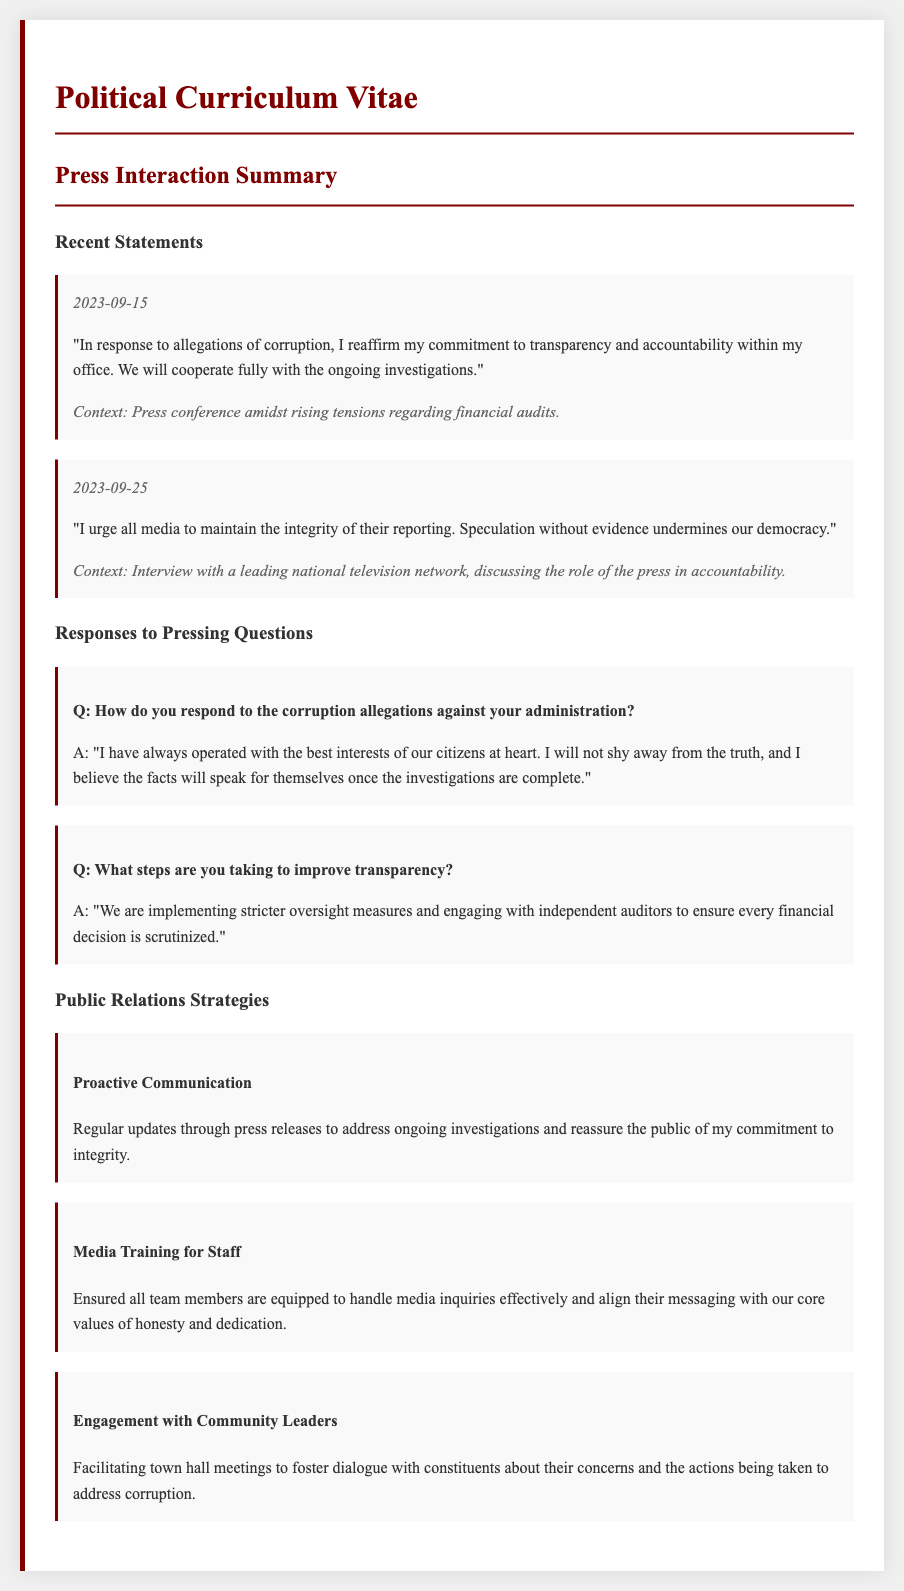What was the date of the press conference addressing corruption allegations? The date mentioned in the document for the press conference is when the allegations were addressed, which is 2023-09-15.
Answer: 2023-09-15 What commitment did the politician reaffirm during the press conference? The statement from the press conference affirms a commitment to a specific principle in relation to governance.
Answer: Transparency and accountability What does the politician urge the media to maintain? The document contains a specific suggestion directed at the media regarding their reporting standards.
Answer: Integrity of their reporting What investigative measure is being implemented to enhance transparency? The document states a specific action being taken to ensure financial decisions are closely monitored.
Answer: Stricter oversight measures What type of meetings are being facilitated to engage with the community? The document includes a reference to a specific type of interaction intended for community engagement.
Answer: Town hall meetings What is the focus of the proactive communication strategy mentioned? The document illustrates the purpose of regular updates, particularly in relation to ongoing situations.
Answer: Address ongoing investigations How many recent statements are listed in the summary? The document includes a total count of entries in the recent statements section.
Answer: Two statements What training is provided to enhance media interactions? The document specifies a strategy aimed at preparing staff for engaging with the press effectively.
Answer: Media Training for Staff 